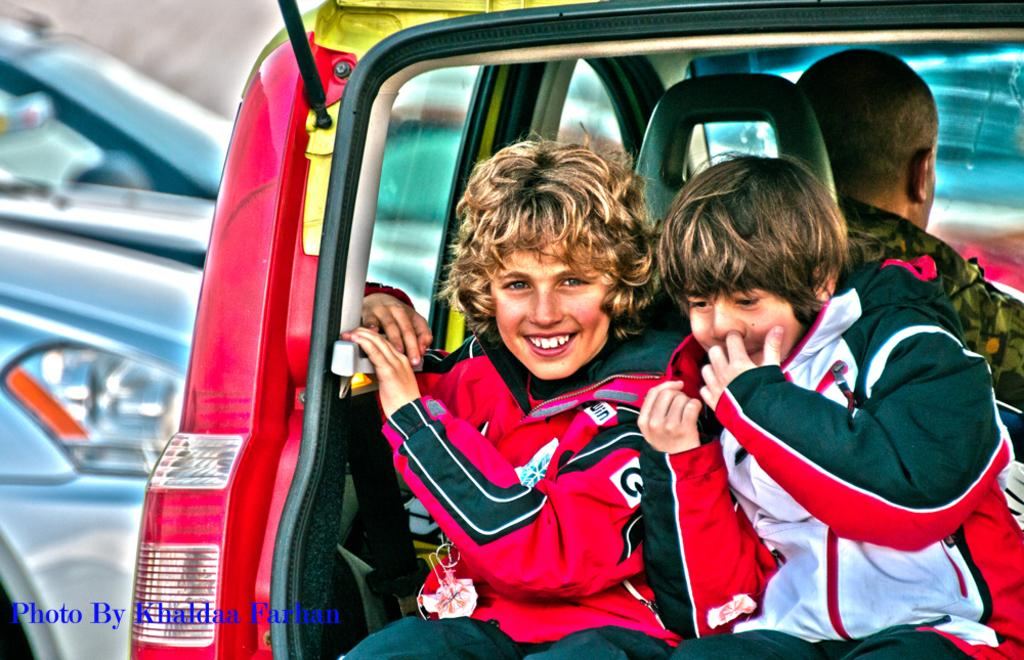How many kids are present in the image? There are two kids in the image. What are the kids wearing? The kids are wearing white and black jackets. Where are the kids sitting in the image? The kids are sitting in the backside of a car. What can be seen in the background of the image? There are many cars in the background of the image. What type of bean is visible in the image? There is no bean present in the image. Can you describe the mist in the image? There is no mist present in the image. 